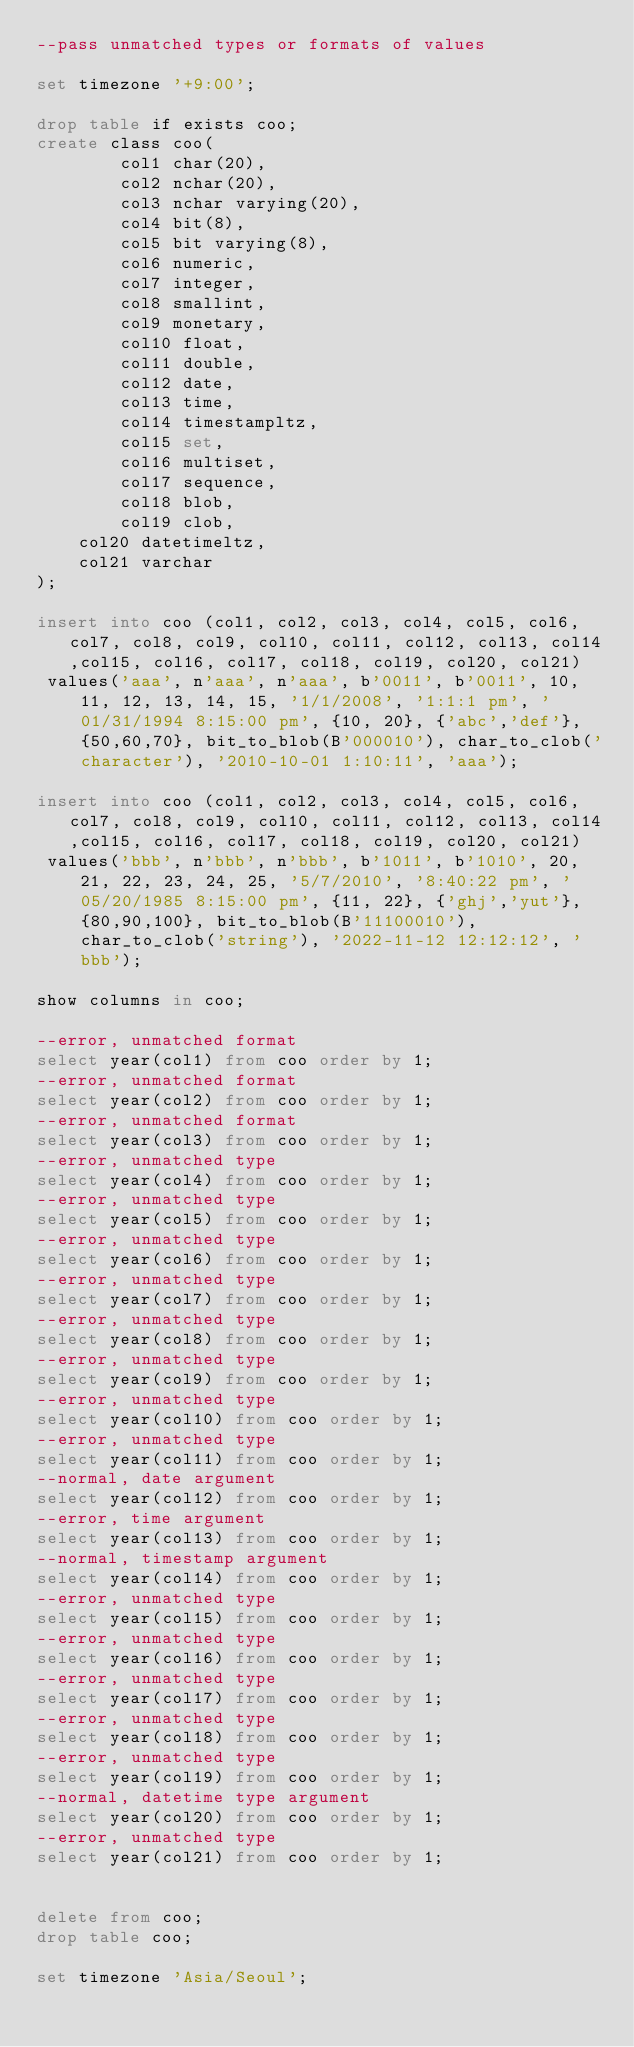<code> <loc_0><loc_0><loc_500><loc_500><_SQL_>--pass unmatched types or formats of values

set timezone '+9:00';

drop table if exists coo;
create class coo(
        col1 char(20),
        col2 nchar(20),
        col3 nchar varying(20),
        col4 bit(8),
        col5 bit varying(8),
        col6 numeric,
        col7 integer,
        col8 smallint,
        col9 monetary,
        col10 float,
        col11 double,
        col12 date,
        col13 time,
        col14 timestampltz,
        col15 set,
        col16 multiset,
        col17 sequence,
        col18 blob,
        col19 clob,
		col20 datetimeltz,
		col21 varchar
);

insert into coo (col1, col2, col3, col4, col5, col6, col7, col8, col9, col10, col11, col12, col13, col14,col15, col16, col17, col18, col19, col20, col21)
 values('aaa', n'aaa', n'aaa', b'0011', b'0011', 10, 11, 12, 13, 14, 15, '1/1/2008', '1:1:1 pm', '01/31/1994 8:15:00 pm', {10, 20}, {'abc','def'}, {50,60,70}, bit_to_blob(B'000010'), char_to_clob('character'), '2010-10-01 1:10:11', 'aaa');

insert into coo (col1, col2, col3, col4, col5, col6, col7, col8, col9, col10, col11, col12, col13, col14,col15, col16, col17, col18, col19, col20, col21)
 values('bbb', n'bbb', n'bbb', b'1011', b'1010', 20, 21, 22, 23, 24, 25, '5/7/2010', '8:40:22 pm', '05/20/1985 8:15:00 pm', {11, 22}, {'ghj','yut'}, {80,90,100}, bit_to_blob(B'11100010'), char_to_clob('string'), '2022-11-12 12:12:12', 'bbb');

show columns in coo;

--error, unmatched format
select year(col1) from coo order by 1;
--error, unmatched format
select year(col2) from coo order by 1;
--error, unmatched format
select year(col3) from coo order by 1;
--error, unmatched type
select year(col4) from coo order by 1;
--error, unmatched type
select year(col5) from coo order by 1;
--error, unmatched type
select year(col6) from coo order by 1;
--error, unmatched type
select year(col7) from coo order by 1;
--error, unmatched type
select year(col8) from coo order by 1;
--error, unmatched type
select year(col9) from coo order by 1;
--error, unmatched type
select year(col10) from coo order by 1;
--error, unmatched type
select year(col11) from coo order by 1;
--normal, date argument
select year(col12) from coo order by 1;
--error, time argument
select year(col13) from coo order by 1;
--normal, timestamp argument
select year(col14) from coo order by 1;
--error, unmatched type
select year(col15) from coo order by 1;
--error, unmatched type
select year(col16) from coo order by 1;
--error, unmatched type
select year(col17) from coo order by 1;
--error, unmatched type
select year(col18) from coo order by 1;
--error, unmatched type
select year(col19) from coo order by 1;
--normal, datetime type argument
select year(col20) from coo order by 1;
--error, unmatched type
select year(col21) from coo order by 1;


delete from coo;
drop table coo;

set timezone 'Asia/Seoul';
</code> 